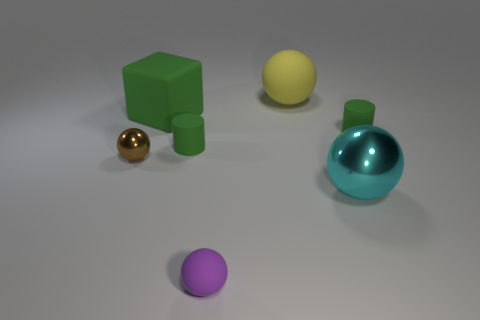How many other objects are there of the same shape as the small purple thing?
Offer a terse response. 3. There is a rubber cube that is the same size as the yellow sphere; what color is it?
Offer a very short reply. Green. How many spheres are cyan objects or tiny rubber things?
Keep it short and to the point. 2. What number of large brown balls are there?
Provide a short and direct response. 0. Do the brown metal object and the small rubber thing to the right of the cyan ball have the same shape?
Keep it short and to the point. No. What number of things are yellow things or small green rubber objects?
Your answer should be very brief. 3. What shape is the tiny rubber thing to the right of the tiny ball right of the large matte cube?
Ensure brevity in your answer.  Cylinder. Is the shape of the big rubber thing that is to the left of the purple matte ball the same as  the cyan object?
Make the answer very short. No. What size is the yellow object that is made of the same material as the purple sphere?
Provide a succinct answer. Large. How many things are metal balls that are on the right side of the green cube or rubber balls that are in front of the big cyan metallic ball?
Make the answer very short. 2. 